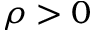<formula> <loc_0><loc_0><loc_500><loc_500>\rho > 0</formula> 